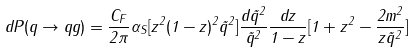Convert formula to latex. <formula><loc_0><loc_0><loc_500><loc_500>d P ( q \rightarrow q g ) = \frac { C _ { F } } { 2 \pi } \alpha _ { S } [ z ^ { 2 } ( 1 - z ) ^ { 2 } \tilde { q } ^ { 2 } ] \frac { d \tilde { q } ^ { 2 } } { \tilde { q } ^ { 2 } } \frac { d z } { 1 - z } [ 1 + z ^ { 2 } - \frac { 2 m ^ { 2 } } { z \tilde { q } ^ { 2 } } ]</formula> 